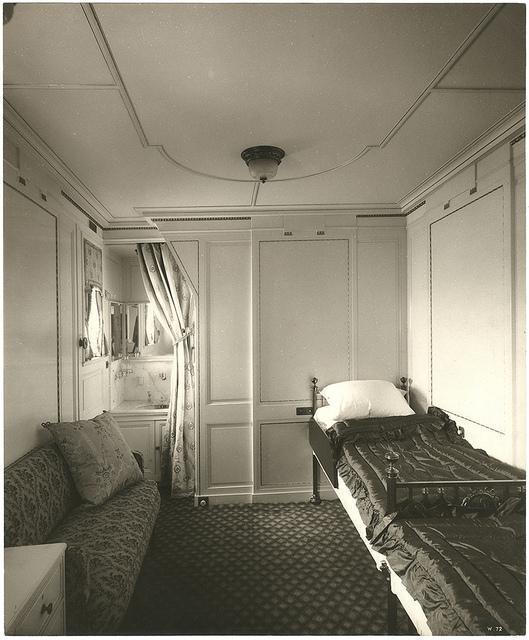How many pillows are on the couch?
Give a very brief answer. 1. 